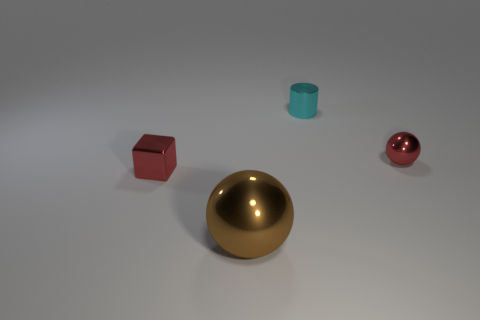What number of tiny things are red metallic things or cyan metal objects?
Ensure brevity in your answer.  3. What color is the big sphere that is the same material as the cyan thing?
Ensure brevity in your answer.  Brown. How many red spheres have the same material as the brown thing?
Offer a terse response. 1. Does the metal thing that is behind the red sphere have the same size as the metallic sphere to the left of the cyan object?
Your answer should be very brief. No. Are there fewer metal cubes that are in front of the small metal cube than red things right of the cyan cylinder?
Your response must be concise. Yes. There is a sphere that is the same color as the small block; what material is it?
Your answer should be compact. Metal. Is there anything else that has the same shape as the cyan metal thing?
Your answer should be compact. No. There is a sphere that is behind the cube; what is its material?
Your answer should be very brief. Metal. Is there anything else that is the same size as the red sphere?
Make the answer very short. Yes. There is a cylinder; are there any small red things on the left side of it?
Make the answer very short. Yes. 